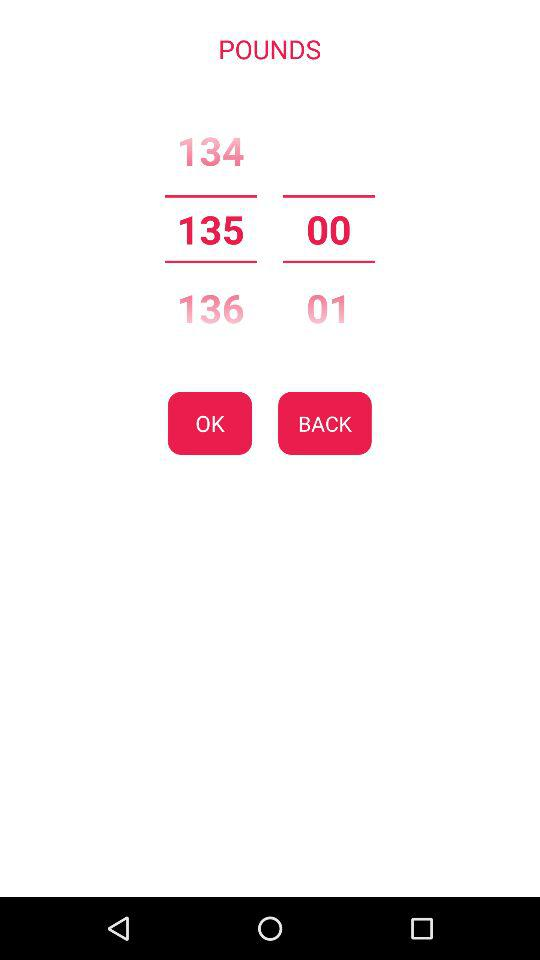How many digits are in the value of the second text input?
Answer the question using a single word or phrase. 2 